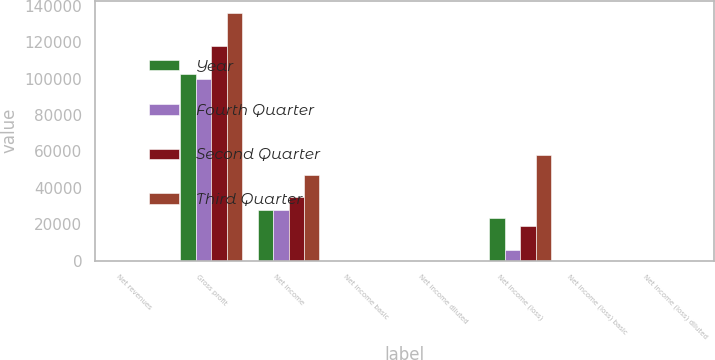<chart> <loc_0><loc_0><loc_500><loc_500><stacked_bar_chart><ecel><fcel>Net revenues<fcel>Gross profit<fcel>Net income<fcel>Net income basic<fcel>Net income diluted<fcel>Net income (loss)<fcel>Net income (loss) basic<fcel>Net income (loss) diluted<nl><fcel>Year<fcel>0.295<fcel>102554<fcel>28010<fcel>0.16<fcel>0.16<fcel>23584<fcel>0.14<fcel>0.14<nl><fcel>Fourth Quarter<fcel>0.295<fcel>99854<fcel>27744<fcel>0.16<fcel>0.15<fcel>5678<fcel>0.03<fcel>0.03<nl><fcel>Second Quarter<fcel>0.295<fcel>118266<fcel>34736<fcel>0.2<fcel>0.19<fcel>18740<fcel>0.11<fcel>0.11<nl><fcel>Third Quarter<fcel>0.295<fcel>136159<fcel>46804<fcel>0.26<fcel>0.25<fcel>58337<fcel>0.34<fcel>0.33<nl></chart> 